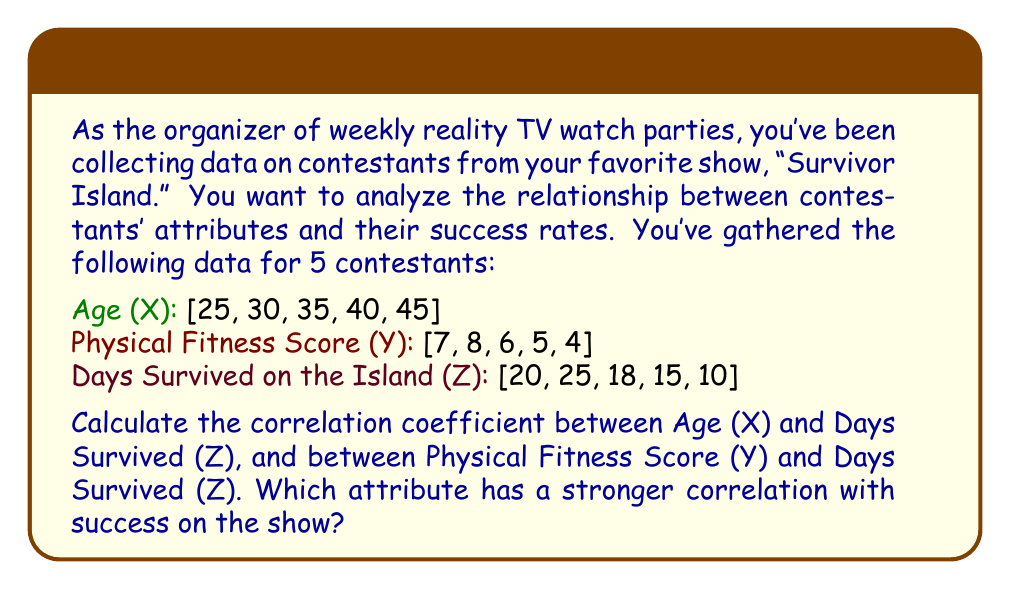Could you help me with this problem? To solve this problem, we'll use the Pearson correlation coefficient formula:

$$ r_{XY} = \frac{\sum_{i=1}^{n} (X_i - \bar{X})(Y_i - \bar{Y})}{\sqrt{\sum_{i=1}^{n} (X_i - \bar{X})^2 \sum_{i=1}^{n} (Y_i - \bar{Y})^2}} $$

Let's calculate the correlation coefficients step by step:

1. Calculate means:
   $\bar{X} = 35$, $\bar{Y} = 6$, $\bar{Z} = 17.6$

2. Calculate deviations from means:
   X - $\bar{X}$: [-10, -5, 0, 5, 10]
   Y - $\bar{Y}$: [1, 2, 0, -1, -2]
   Z - $\bar{Z}$: [2.4, 7.4, 0.4, -2.6, -7.6]

3. Calculate products of deviations:
   (X - $\bar{X}$)(Z - $\bar{Z}$): [-24, -37, 0, -13, -76]
   (Y - $\bar{Y}$)(Z - $\bar{Z}$): [2.4, 14.8, 0, 2.6, 15.2]

4. Calculate sums of squared deviations:
   $\sum (X - \bar{X})^2 = 250$
   $\sum (Y - \bar{Y})^2 = 10$
   $\sum (Z - \bar{Z})^2 = 134.24$

5. Apply the correlation coefficient formula:

   For Age and Days Survived:
   $$ r_{XZ} = \frac{-150}{\sqrt{250 \times 134.24}} \approx -0.8165 $$

   For Physical Fitness and Days Survived:
   $$ r_{YZ} = \frac{35}{\sqrt{10 \times 134.24}} \approx 0.9539 $$

The correlation coefficient ranges from -1 to 1, where -1 indicates a perfect negative correlation, 0 indicates no correlation, and 1 indicates a perfect positive correlation.
Answer: The correlation coefficient between Age and Days Survived is approximately -0.8165, indicating a strong negative correlation. The correlation coefficient between Physical Fitness Score and Days Survived is approximately 0.9539, indicating a very strong positive correlation. Physical Fitness Score has a stronger correlation with success on the show, as its correlation coefficient is closer to 1 in absolute value. 